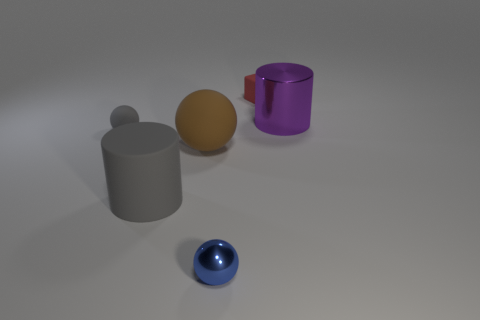Add 2 large brown rubber things. How many objects exist? 8 Subtract all cylinders. How many objects are left? 4 Subtract 1 blue spheres. How many objects are left? 5 Subtract all large brown objects. Subtract all balls. How many objects are left? 2 Add 4 matte objects. How many matte objects are left? 8 Add 4 small gray matte spheres. How many small gray matte spheres exist? 5 